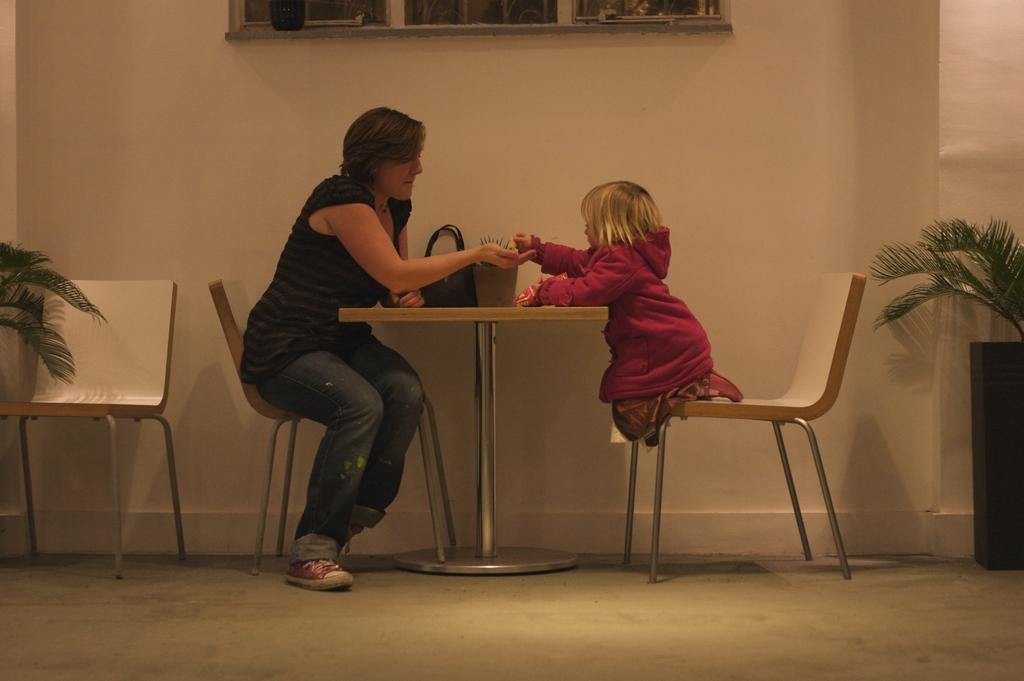What color is the wall in the image? The wall in the image is white. What can be seen on the wall in the image? There is a window on the wall in the image. What furniture is present in the image? There are chairs and a table in the image. What objects are on the table in the image? There is a basket and a handbag on the table in the image. How many people are sitting in the chairs in the image? Two people are sitting on the chairs in the image. What type of fifth is being served in the image? There is no mention of any food or drink being served in the image, so it is not possible to determine if a fifth is present or what type it might be. 